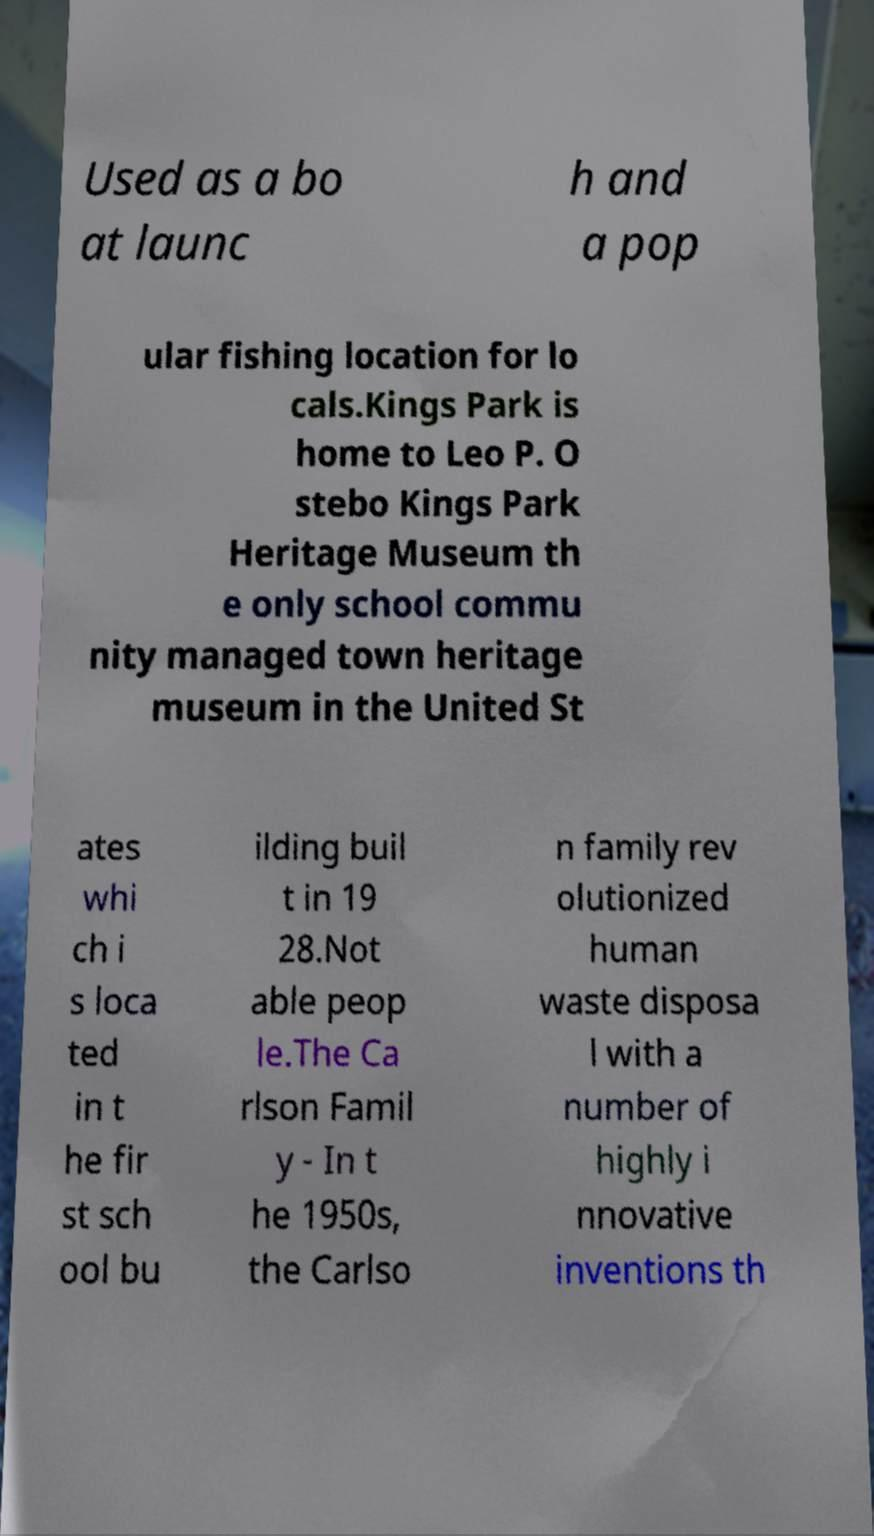There's text embedded in this image that I need extracted. Can you transcribe it verbatim? Used as a bo at launc h and a pop ular fishing location for lo cals.Kings Park is home to Leo P. O stebo Kings Park Heritage Museum th e only school commu nity managed town heritage museum in the United St ates whi ch i s loca ted in t he fir st sch ool bu ilding buil t in 19 28.Not able peop le.The Ca rlson Famil y - In t he 1950s, the Carlso n family rev olutionized human waste disposa l with a number of highly i nnovative inventions th 